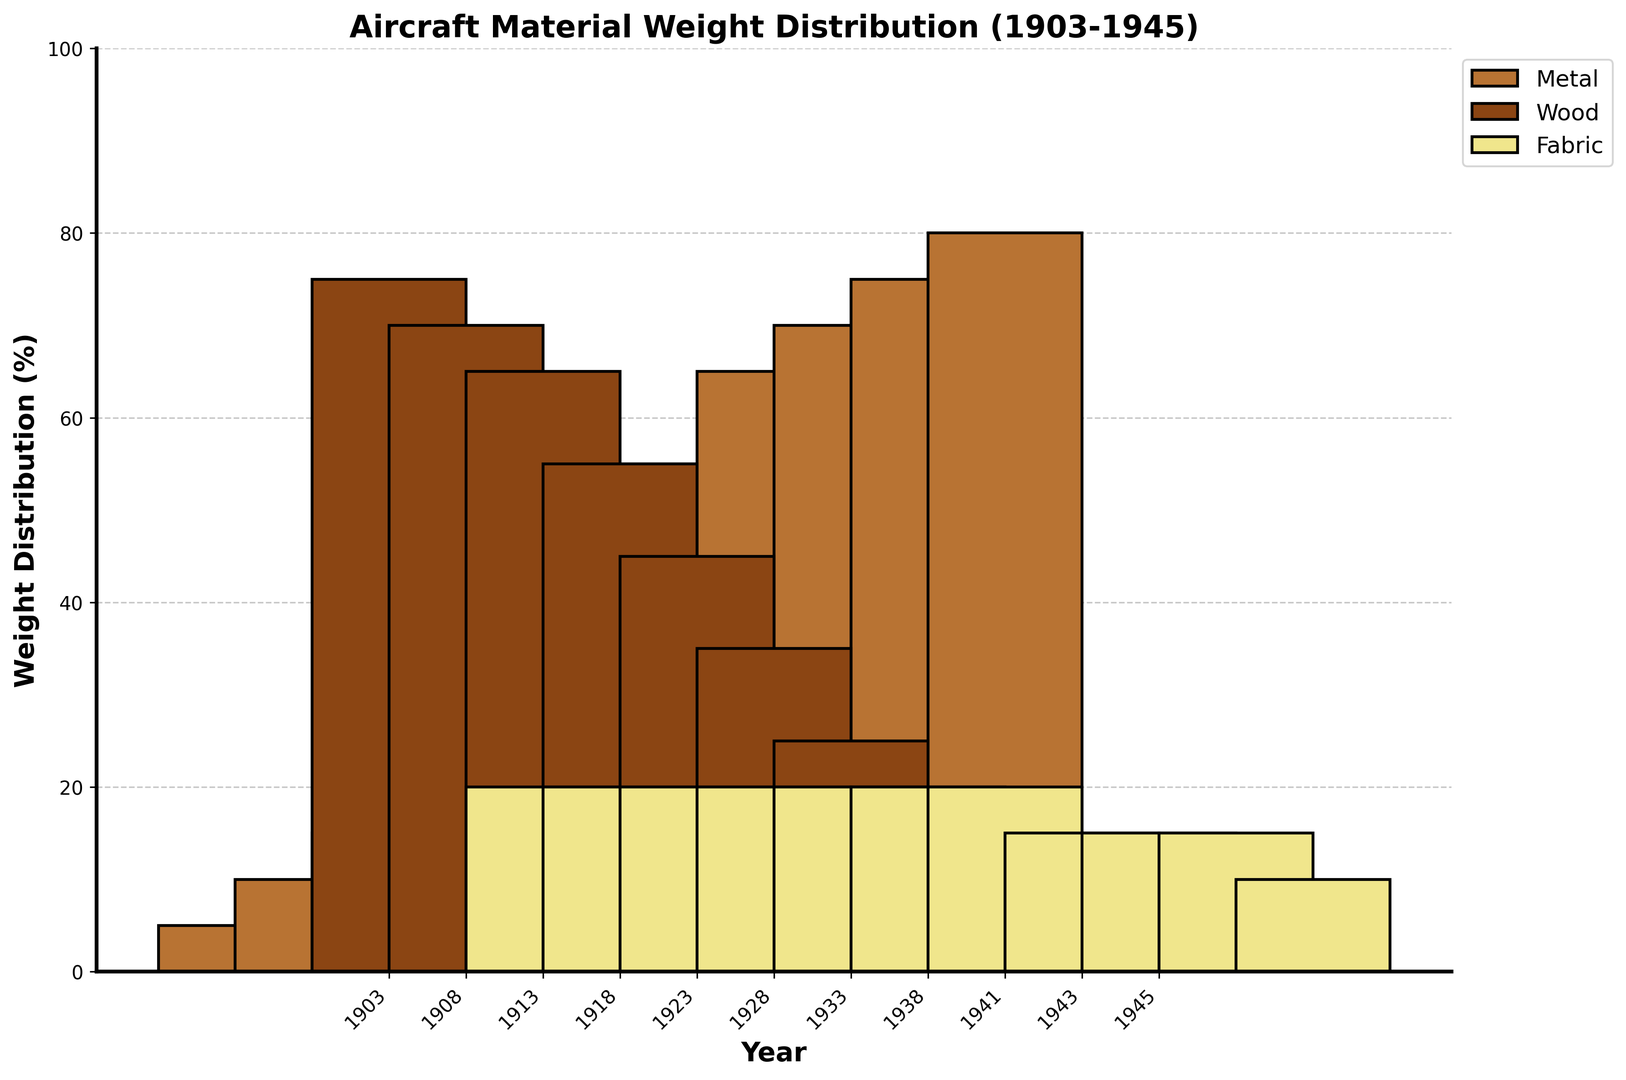What year did metal first surpass wood in the weight distribution for aircraft construction? We need to look for the point where the metal bar is higher than the wood bar. The first year this happens is in 1933.
Answer: 1933 Which material shows the most significant decrease throughout the years from 1903 to 1945? Compare the height of the bars for metal, wood, and fabric from the beginning to the end of the period. Fabric decreases by 10%, wood decreases by 65%, and metal increases. Therefore, wood shows the most significant decrease.
Answer: Wood What is the total weight percentage of wood and fabric used in 1928? The weight percentages of wood and fabric in 1928 are 35% and 20%, respectively. Sum them up: 35 + 20 = 55.
Answer: 55% Which year shows the smallest difference in weight distribution between metal and wood? Identify the year where the difference between the metal bar and the wood bar is the smallest. The smallest difference observed seems to be in 1941, where the metal is 70% and wood is 15%, resulting in a difference of 55%.
Answer: 1941 What trend can be observed for fabric usage over the years? Fabric usage remains mostly constant with a slight decrease towards the end of the period, from 20% to 10%.
Answer: Mostly constant, slight decrease In which year does metal exceed fabric by exactly 60 percent? We need to find a year where the difference between metal and fabric bars is 60%. In 1923, metal is 35% and fabric is 20%, which is a difference of 15%. Continue checking each year until 1938, where metal is 65% and fabric is 5% yielding a difference of 60%.
Answer: 1938 How does the sum of the weight percentages of all materials used in any given year compare across the years? Sum the metal, wood, and fabric percentages for a few years as a sample (e.g., 1903: 5+75+20 = 100, 1945: 80+10+10 = 100). The sum remains constant at 100% throughout all years.
Answer: Constant at 100% What pattern can be observed in the weight distribution of wood from 1903 to 1945? Observing the height of the wood bars over time, there is a continual decrease from 75% in 1903 to 10% in 1945.
Answer: Continual decrease Which material shows a continuous increase in usage over the years? By observing the height of the bars, metal shows a continuous increase from 5% in 1903 to 80% in 1945.
Answer: Metal 